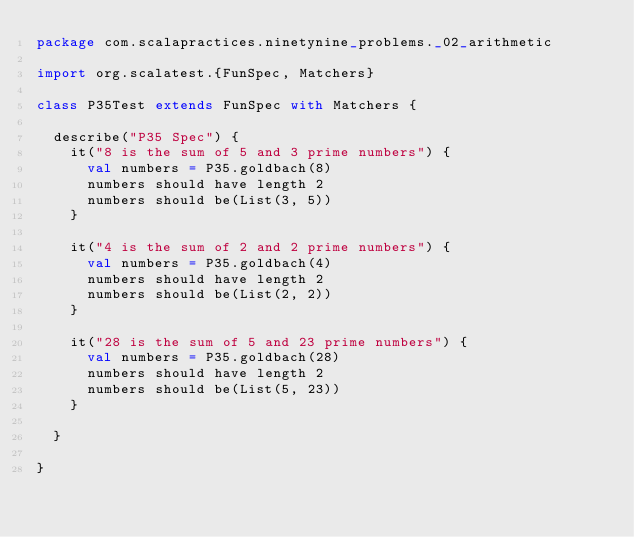<code> <loc_0><loc_0><loc_500><loc_500><_Scala_>package com.scalapractices.ninetynine_problems._02_arithmetic

import org.scalatest.{FunSpec, Matchers}

class P35Test extends FunSpec with Matchers {

  describe("P35 Spec") {
    it("8 is the sum of 5 and 3 prime numbers") {
      val numbers = P35.goldbach(8)
      numbers should have length 2
      numbers should be(List(3, 5))
    }

    it("4 is the sum of 2 and 2 prime numbers") {
      val numbers = P35.goldbach(4)
      numbers should have length 2
      numbers should be(List(2, 2))
    }

    it("28 is the sum of 5 and 23 prime numbers") {
      val numbers = P35.goldbach(28)
      numbers should have length 2
      numbers should be(List(5, 23))
    }

  }

}</code> 